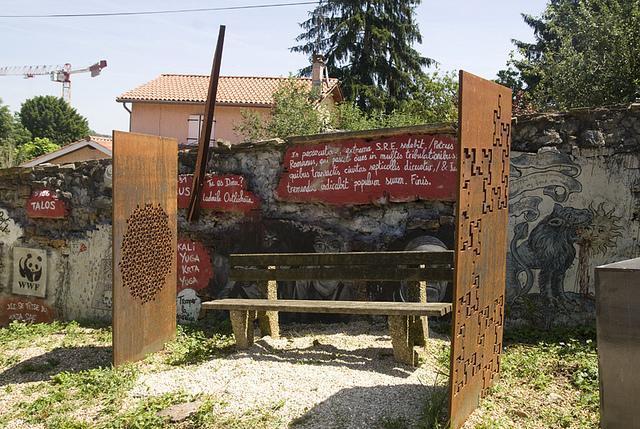How many train cars are on the right of the man ?
Give a very brief answer. 0. 